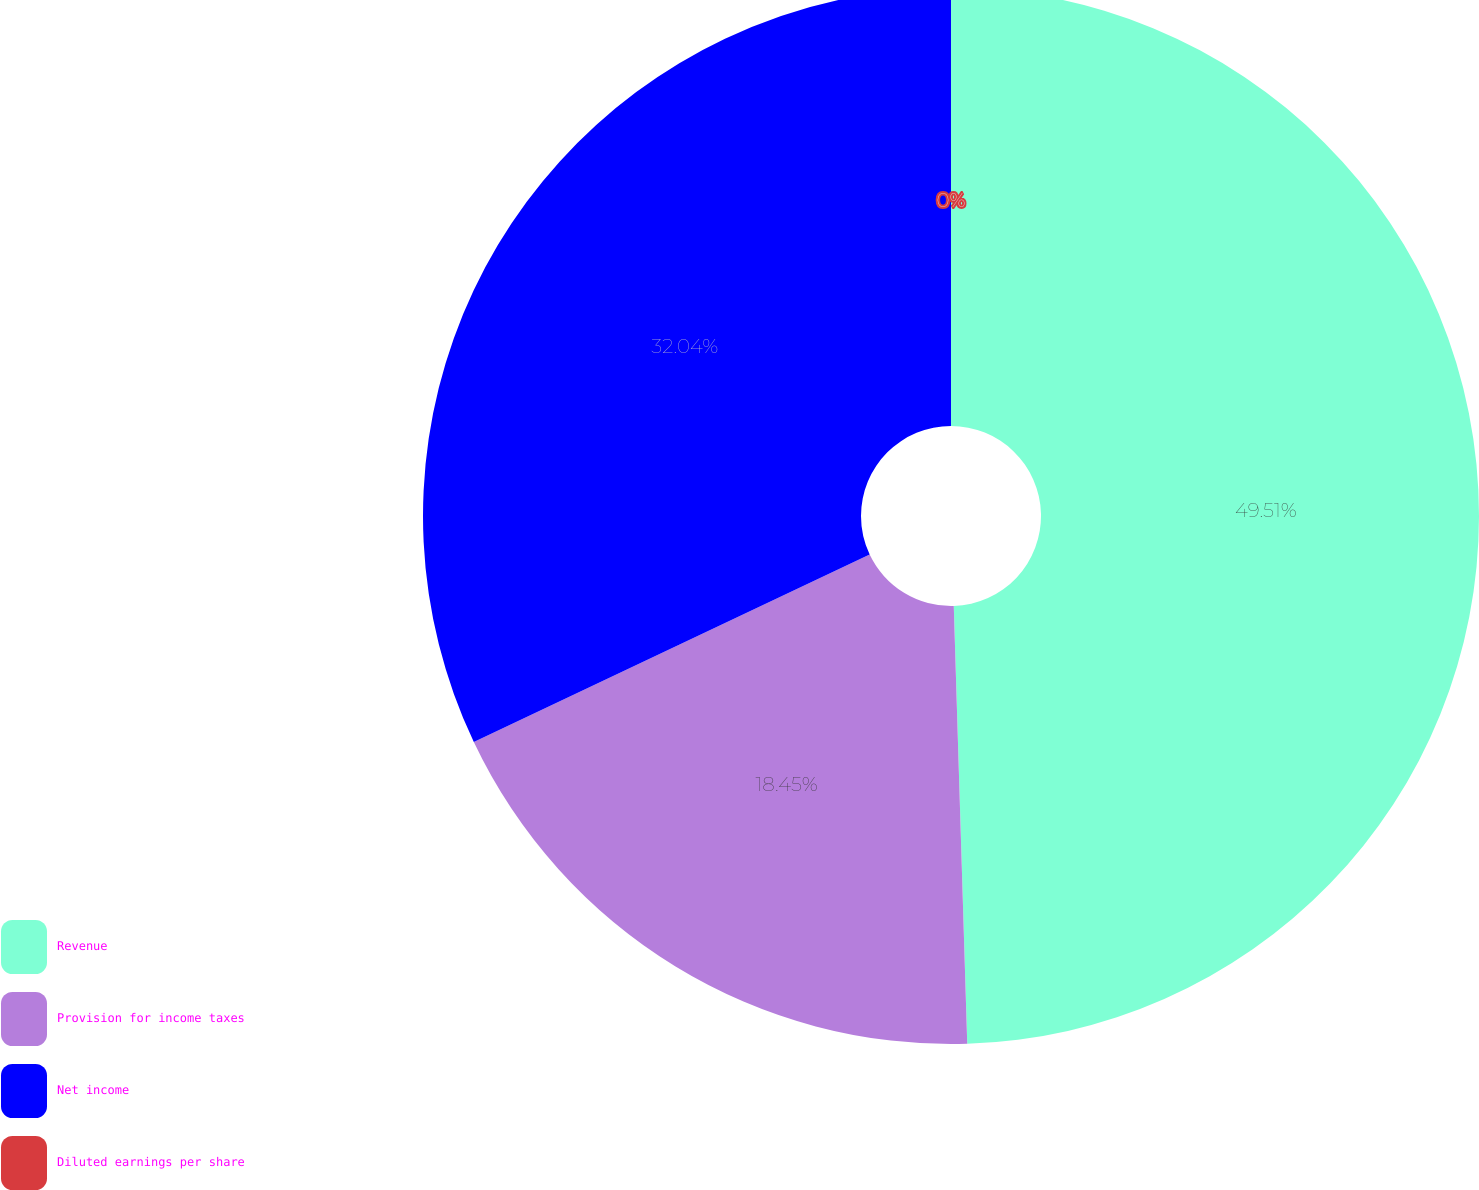Convert chart to OTSL. <chart><loc_0><loc_0><loc_500><loc_500><pie_chart><fcel>Revenue<fcel>Provision for income taxes<fcel>Net income<fcel>Diluted earnings per share<nl><fcel>49.51%<fcel>18.45%<fcel>32.04%<fcel>0.0%<nl></chart> 